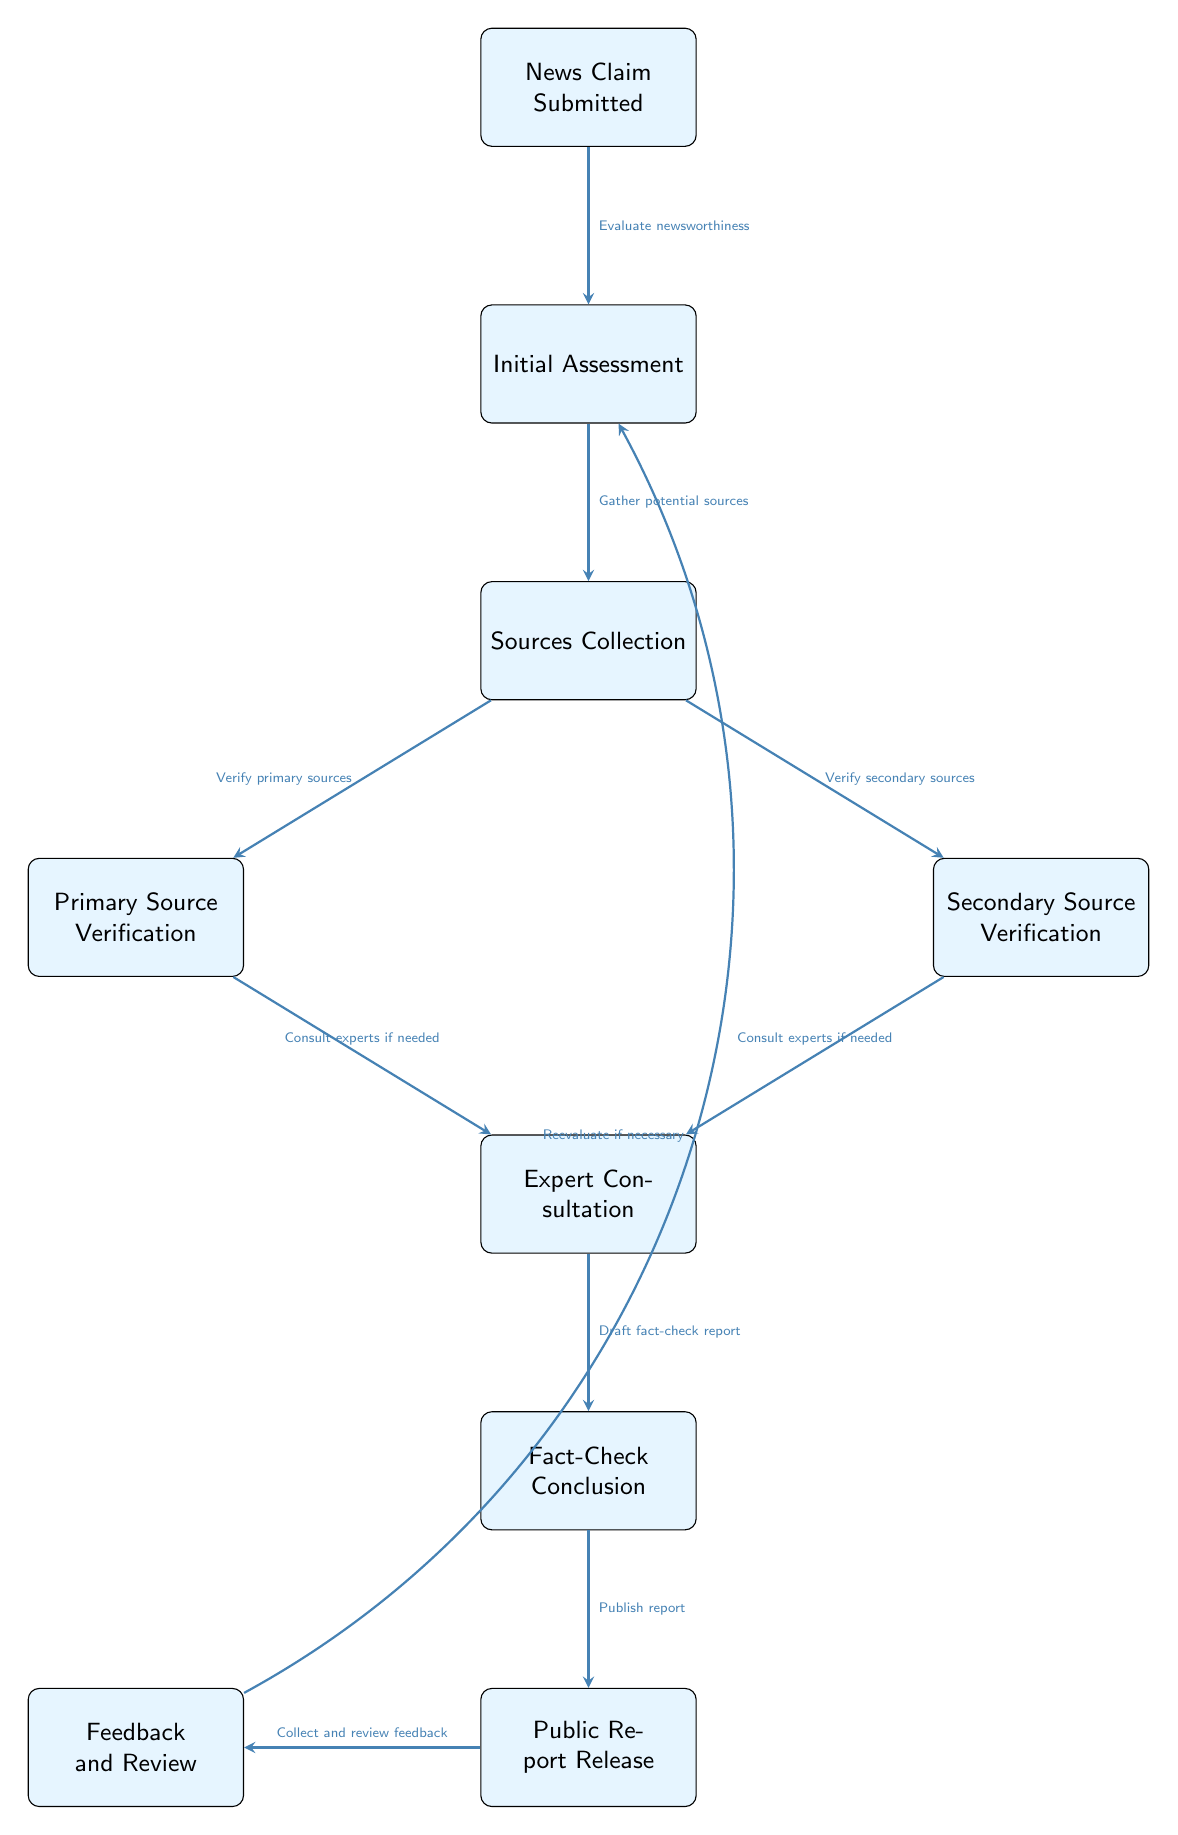What's the first step in the fact-checking process? The diagram shows the first node as "News Claim Submitted," which indicates the initial action in the fact-checking process.
Answer: News Claim Submitted How many main verification steps are present in the process? The process includes two main verification steps: "Primary Source Verification" and "Secondary Source Verification," both stemming from the "Sources Collection" node.
Answer: Two What happens after the "Fact-Check Conclusion"? According to the diagram, the next node after "Fact-Check Conclusion" is "Public Report Release," indicating that a report is published following the conclusion.
Answer: Public Report Release How does feedback influence the process? The diagram illustrates that "Feedback and Review" occurs after the "Public Report Release," and it shows that feedback can lead back to the "Initial Assessment" if reevaluation is necessary.
Answer: Reevaluate if necessary What action occurs between "Sources Collection" and "Fact-Check Conclusion"? There are two verification paths: "Primary Source Verification" and "Secondary Source Verification," followed by "Expert Consultation" that contribute to the "Fact-Check Conclusion."
Answer: Verify primary and secondary sources, consult experts What is the final outcome of the fact-checking process? The last node in the diagram is "Public Report Release," which represents the outcome of all preceding steps in the fact-checking process.
Answer: Public Report Release What is evaluated during the "Initial Assessment"? The diagram states that during "Initial Assessment," the action taken is to "Evaluate newsworthiness," which determines if the claim should be further investigated.
Answer: Evaluate newsworthiness How many consultative processes are present in the diagram? There is one consultative process that involves consulting experts if needed, which arises from both primary and secondary source verifications.
Answer: One 